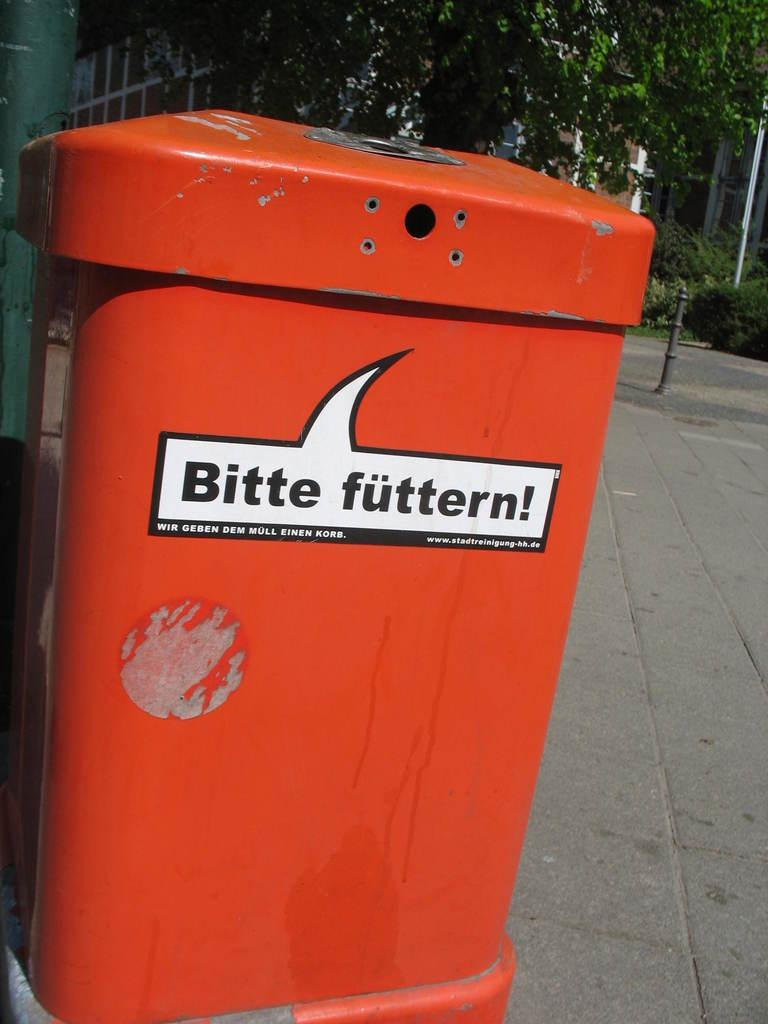<image>
Render a clear and concise summary of the photo. the word Bitte is on the orange item outside 